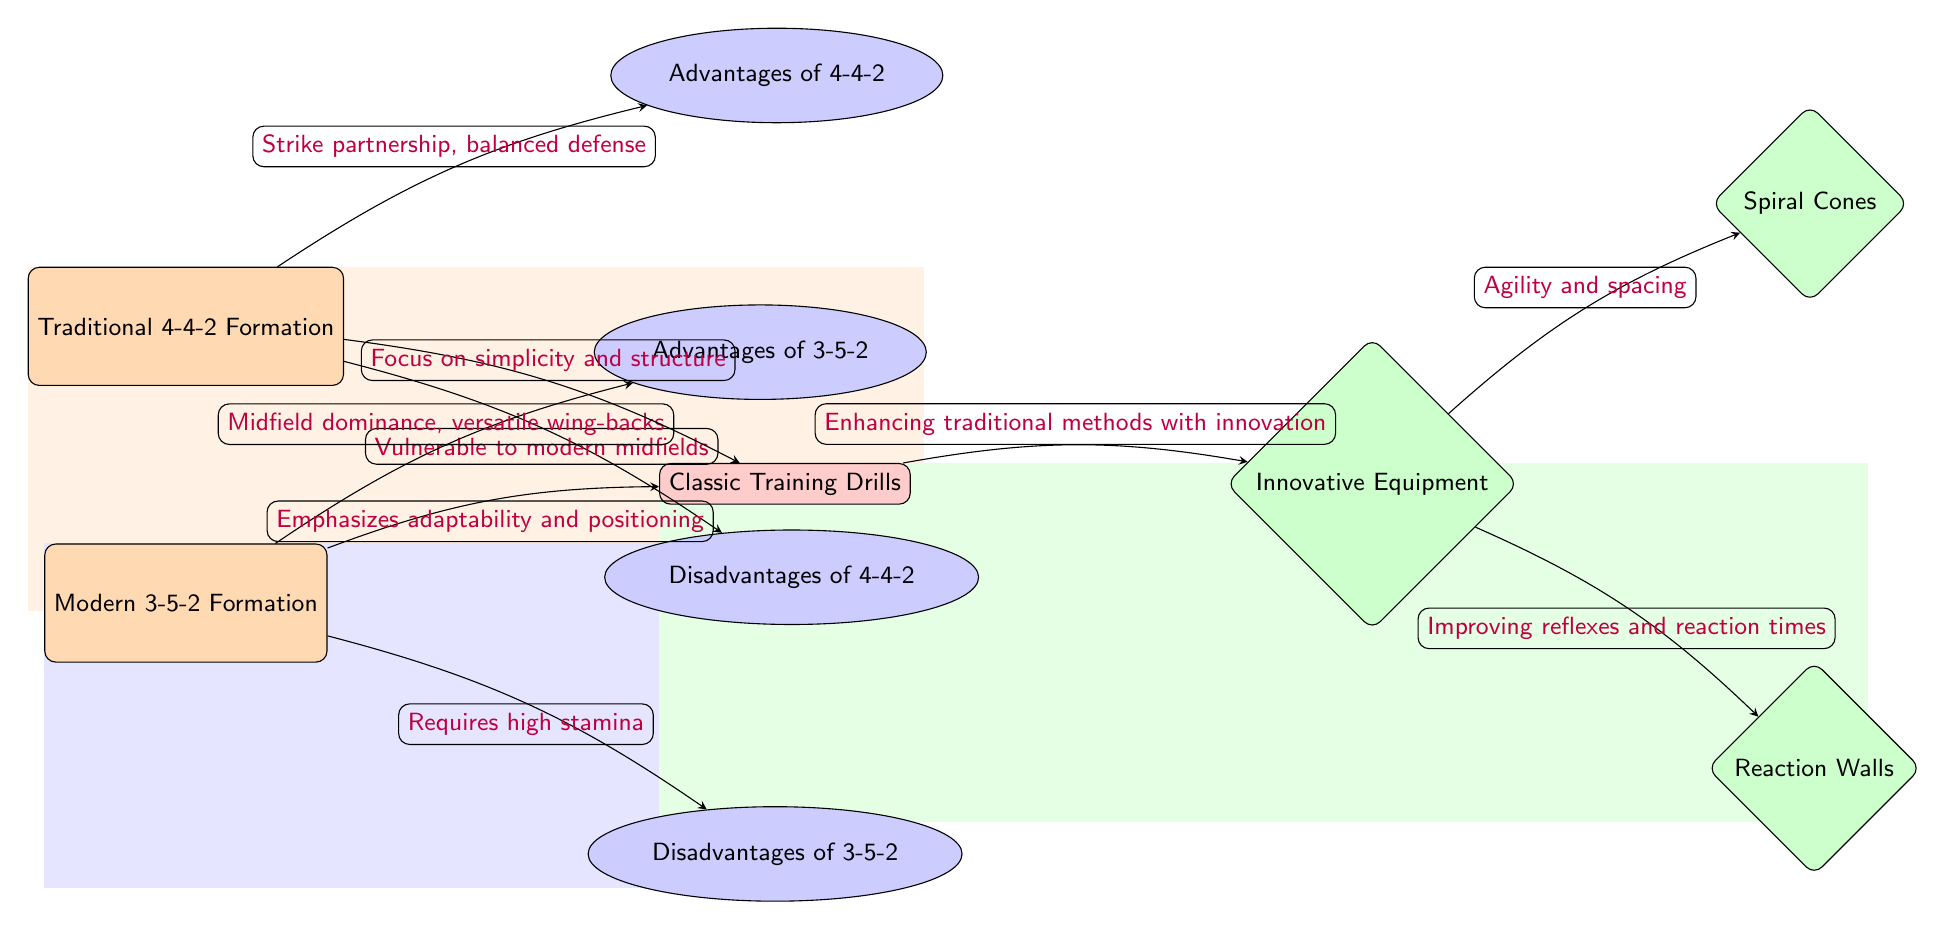What is the main focus of the Traditional 4-4-2 Formation? The diagram indicates that the main focus of the Traditional 4-4-2 Formation is "Strike partnership, balanced defense," as shown in the edge leading to the advantages of this formation from the node itself.
Answer: Strike partnership, balanced defense What are two advantages of the Modern 3-5-2 Formation? The advantages of the Modern 3-5-2 Formation listed in the diagram are "Midfield dominance" and "versatile wing-backs," both of which connect from the advantages aspect node of this formation.
Answer: Midfield dominance, versatile wing-backs What is the disadvantage mentioned for the Traditional 4-4-2? According to the diagram, the disadvantage listed for the Traditional 4-4-2 Formation is "Vulnerable to modern midfields," which connects directly from the disadvantage aspect node of this formation.
Answer: Vulnerable to modern midfields How does the training method for the Traditional 4-4-2 emphasize its structure? The training method connected to the Traditional 4-4-2 emphasizes its focus on structure and simplicity, as indicated by the edge linking the training node to the 4-4-2 formation node.
Answer: Focus on simplicity and structure What is the relationship between Innovative Equipment and Reaction Walls? In the diagram, the relationship shows that Innovative Equipment leads to two aspects: "Agility and spacing" and "Improving reflexes and reaction times," where Reaction Walls specifically relates to the improvement of reflexes and reaction times.
Answer: Improving reflexes and reaction times What overall approach does the 3-5-2 Formation require? From the diagram, it is evident that the overall approach of the 3-5-2 Formation requires "high stamina," as shown in the disadvantage aspect related to this formation.
Answer: High stamina Which training method enhances traditional methods with innovation? The training method that enhances traditional methods with innovation is shown in the diagram as connecting directly from the training node to the equipment node, and this is specifically the "Innovative Equipment."
Answer: Enhancing traditional methods with innovation What type of diagram layout is used in this depiction? The layout used in this depiction is a flowchart-style layout with nodes and directed edges, illustrating relationships and aspects clearly throughout the diagram.
Answer: Flowchart-style layout 